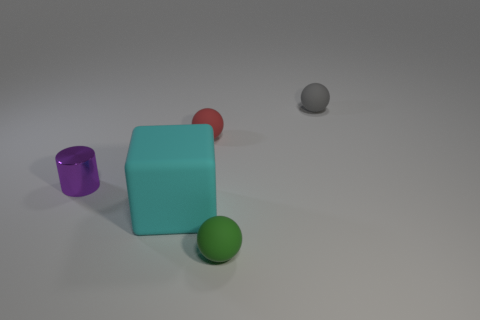Add 4 tiny green matte objects. How many objects exist? 9 Subtract all cyan spheres. Subtract all gray cylinders. How many spheres are left? 3 Subtract all cubes. How many objects are left? 4 Subtract all small red rubber objects. Subtract all gray balls. How many objects are left? 3 Add 1 rubber spheres. How many rubber spheres are left? 4 Add 3 cylinders. How many cylinders exist? 4 Subtract 0 green blocks. How many objects are left? 5 